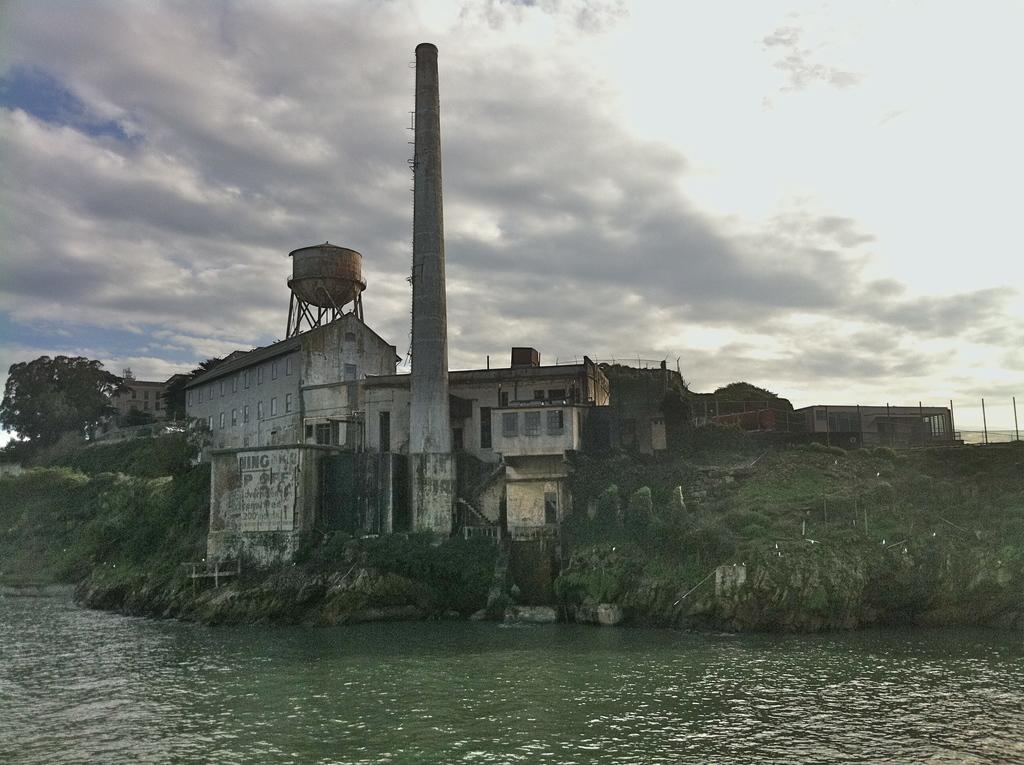Describe this image in one or two sentences. In this image, I can see a storage tank, tower, buildings and trees on a hill. At the bottom of the image, there is water. In the background, I can see the sky. 